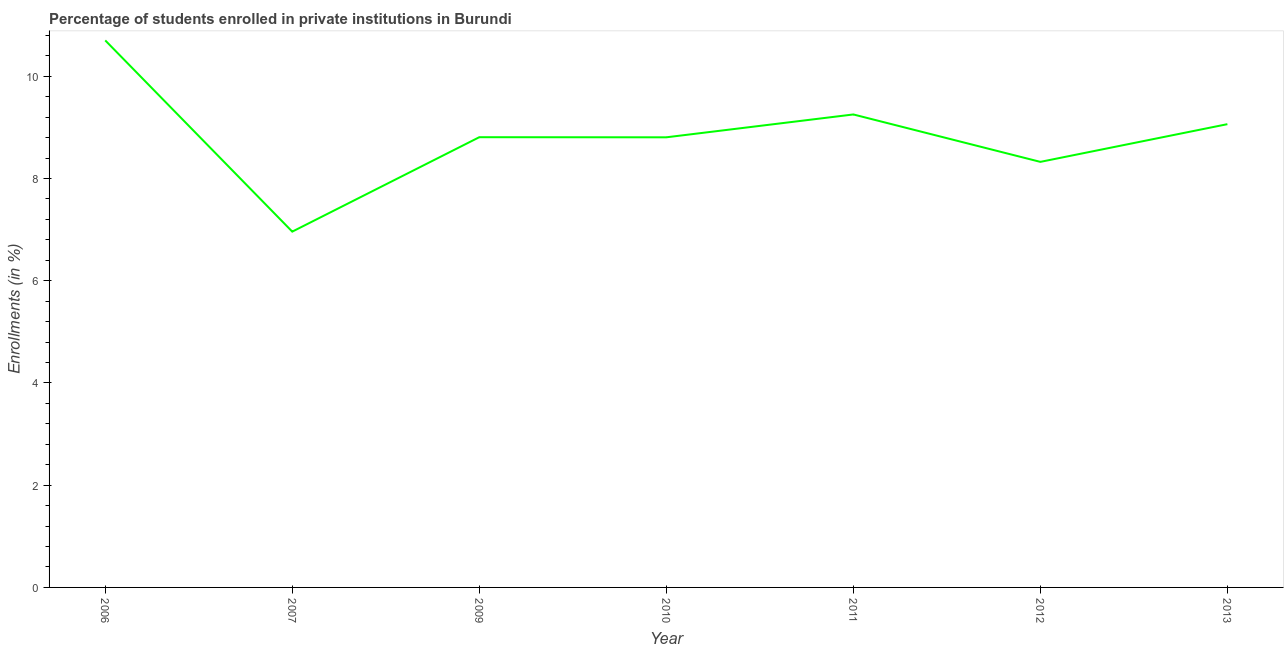What is the enrollments in private institutions in 2012?
Provide a short and direct response. 8.32. Across all years, what is the maximum enrollments in private institutions?
Make the answer very short. 10.7. Across all years, what is the minimum enrollments in private institutions?
Your response must be concise. 6.96. What is the sum of the enrollments in private institutions?
Ensure brevity in your answer.  61.91. What is the difference between the enrollments in private institutions in 2009 and 2010?
Give a very brief answer. 0. What is the average enrollments in private institutions per year?
Keep it short and to the point. 8.84. What is the median enrollments in private institutions?
Your response must be concise. 8.81. What is the ratio of the enrollments in private institutions in 2010 to that in 2013?
Offer a terse response. 0.97. Is the difference between the enrollments in private institutions in 2006 and 2009 greater than the difference between any two years?
Your response must be concise. No. What is the difference between the highest and the second highest enrollments in private institutions?
Ensure brevity in your answer.  1.45. What is the difference between the highest and the lowest enrollments in private institutions?
Offer a terse response. 3.74. In how many years, is the enrollments in private institutions greater than the average enrollments in private institutions taken over all years?
Offer a terse response. 3. Does the enrollments in private institutions monotonically increase over the years?
Make the answer very short. No. How many years are there in the graph?
Make the answer very short. 7. Are the values on the major ticks of Y-axis written in scientific E-notation?
Ensure brevity in your answer.  No. What is the title of the graph?
Ensure brevity in your answer.  Percentage of students enrolled in private institutions in Burundi. What is the label or title of the X-axis?
Give a very brief answer. Year. What is the label or title of the Y-axis?
Offer a very short reply. Enrollments (in %). What is the Enrollments (in %) of 2006?
Your response must be concise. 10.7. What is the Enrollments (in %) in 2007?
Offer a terse response. 6.96. What is the Enrollments (in %) of 2009?
Give a very brief answer. 8.81. What is the Enrollments (in %) of 2010?
Give a very brief answer. 8.8. What is the Enrollments (in %) in 2011?
Offer a very short reply. 9.25. What is the Enrollments (in %) in 2012?
Your answer should be very brief. 8.32. What is the Enrollments (in %) of 2013?
Give a very brief answer. 9.06. What is the difference between the Enrollments (in %) in 2006 and 2007?
Your answer should be very brief. 3.74. What is the difference between the Enrollments (in %) in 2006 and 2009?
Provide a short and direct response. 1.89. What is the difference between the Enrollments (in %) in 2006 and 2010?
Provide a short and direct response. 1.9. What is the difference between the Enrollments (in %) in 2006 and 2011?
Your answer should be very brief. 1.45. What is the difference between the Enrollments (in %) in 2006 and 2012?
Your answer should be very brief. 2.38. What is the difference between the Enrollments (in %) in 2006 and 2013?
Offer a terse response. 1.64. What is the difference between the Enrollments (in %) in 2007 and 2009?
Offer a terse response. -1.85. What is the difference between the Enrollments (in %) in 2007 and 2010?
Your answer should be very brief. -1.84. What is the difference between the Enrollments (in %) in 2007 and 2011?
Give a very brief answer. -2.29. What is the difference between the Enrollments (in %) in 2007 and 2012?
Make the answer very short. -1.36. What is the difference between the Enrollments (in %) in 2007 and 2013?
Your answer should be very brief. -2.1. What is the difference between the Enrollments (in %) in 2009 and 2010?
Ensure brevity in your answer.  0. What is the difference between the Enrollments (in %) in 2009 and 2011?
Provide a succinct answer. -0.44. What is the difference between the Enrollments (in %) in 2009 and 2012?
Your answer should be very brief. 0.48. What is the difference between the Enrollments (in %) in 2009 and 2013?
Offer a very short reply. -0.26. What is the difference between the Enrollments (in %) in 2010 and 2011?
Make the answer very short. -0.45. What is the difference between the Enrollments (in %) in 2010 and 2012?
Your answer should be compact. 0.48. What is the difference between the Enrollments (in %) in 2010 and 2013?
Offer a very short reply. -0.26. What is the difference between the Enrollments (in %) in 2011 and 2012?
Offer a terse response. 0.93. What is the difference between the Enrollments (in %) in 2011 and 2013?
Your answer should be very brief. 0.19. What is the difference between the Enrollments (in %) in 2012 and 2013?
Provide a succinct answer. -0.74. What is the ratio of the Enrollments (in %) in 2006 to that in 2007?
Your answer should be very brief. 1.54. What is the ratio of the Enrollments (in %) in 2006 to that in 2009?
Provide a succinct answer. 1.22. What is the ratio of the Enrollments (in %) in 2006 to that in 2010?
Make the answer very short. 1.22. What is the ratio of the Enrollments (in %) in 2006 to that in 2011?
Offer a terse response. 1.16. What is the ratio of the Enrollments (in %) in 2006 to that in 2012?
Provide a succinct answer. 1.28. What is the ratio of the Enrollments (in %) in 2006 to that in 2013?
Your answer should be compact. 1.18. What is the ratio of the Enrollments (in %) in 2007 to that in 2009?
Make the answer very short. 0.79. What is the ratio of the Enrollments (in %) in 2007 to that in 2010?
Provide a succinct answer. 0.79. What is the ratio of the Enrollments (in %) in 2007 to that in 2011?
Offer a terse response. 0.75. What is the ratio of the Enrollments (in %) in 2007 to that in 2012?
Keep it short and to the point. 0.84. What is the ratio of the Enrollments (in %) in 2007 to that in 2013?
Make the answer very short. 0.77. What is the ratio of the Enrollments (in %) in 2009 to that in 2012?
Make the answer very short. 1.06. What is the ratio of the Enrollments (in %) in 2010 to that in 2012?
Make the answer very short. 1.06. What is the ratio of the Enrollments (in %) in 2010 to that in 2013?
Offer a very short reply. 0.97. What is the ratio of the Enrollments (in %) in 2011 to that in 2012?
Offer a very short reply. 1.11. What is the ratio of the Enrollments (in %) in 2012 to that in 2013?
Your answer should be very brief. 0.92. 